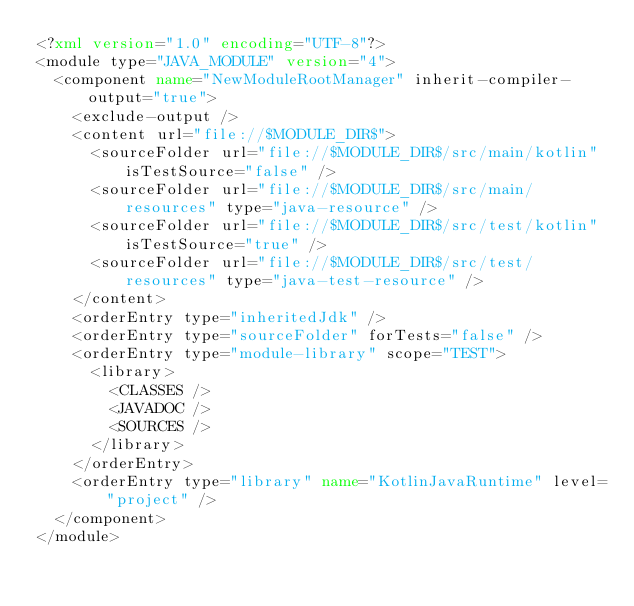<code> <loc_0><loc_0><loc_500><loc_500><_XML_><?xml version="1.0" encoding="UTF-8"?>
<module type="JAVA_MODULE" version="4">
  <component name="NewModuleRootManager" inherit-compiler-output="true">
    <exclude-output />
    <content url="file://$MODULE_DIR$">
      <sourceFolder url="file://$MODULE_DIR$/src/main/kotlin" isTestSource="false" />
      <sourceFolder url="file://$MODULE_DIR$/src/main/resources" type="java-resource" />
      <sourceFolder url="file://$MODULE_DIR$/src/test/kotlin" isTestSource="true" />
      <sourceFolder url="file://$MODULE_DIR$/src/test/resources" type="java-test-resource" />
    </content>
    <orderEntry type="inheritedJdk" />
    <orderEntry type="sourceFolder" forTests="false" />
    <orderEntry type="module-library" scope="TEST">
      <library>
        <CLASSES />
        <JAVADOC />
        <SOURCES />
      </library>
    </orderEntry>
    <orderEntry type="library" name="KotlinJavaRuntime" level="project" />
  </component>
</module></code> 